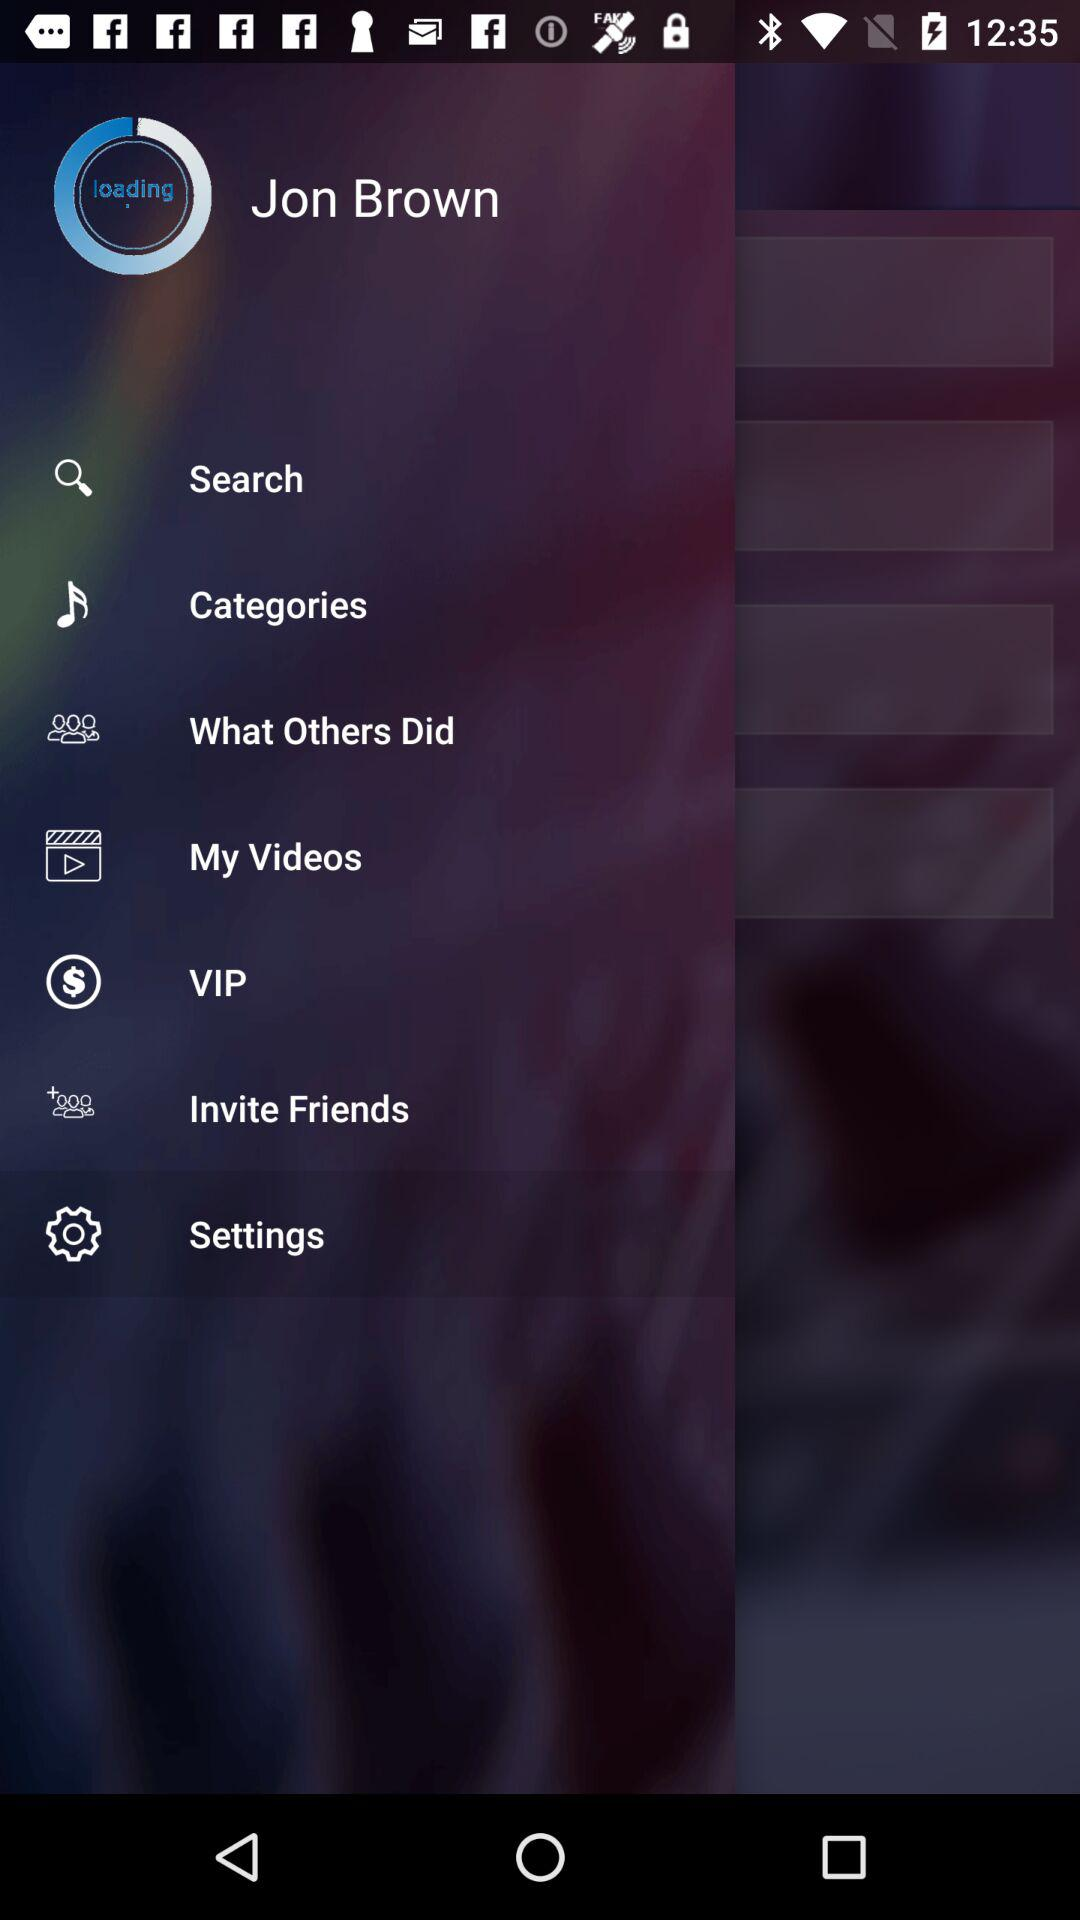How many items are in the menu besides the search bar?
Answer the question using a single word or phrase. 6 